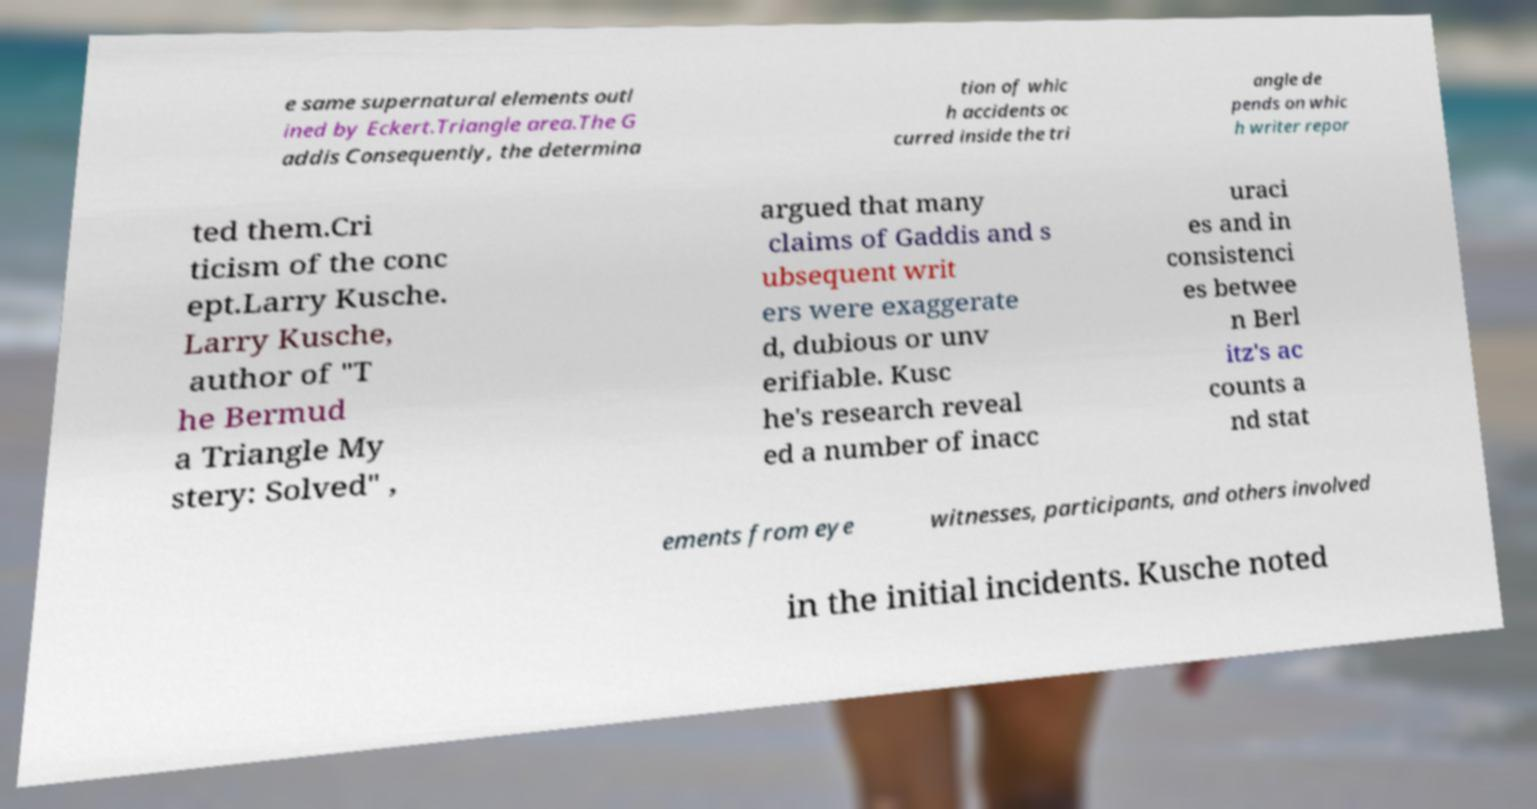Can you read and provide the text displayed in the image?This photo seems to have some interesting text. Can you extract and type it out for me? e same supernatural elements outl ined by Eckert.Triangle area.The G addis Consequently, the determina tion of whic h accidents oc curred inside the tri angle de pends on whic h writer repor ted them.Cri ticism of the conc ept.Larry Kusche. Larry Kusche, author of "T he Bermud a Triangle My stery: Solved" , argued that many claims of Gaddis and s ubsequent writ ers were exaggerate d, dubious or unv erifiable. Kusc he's research reveal ed a number of inacc uraci es and in consistenci es betwee n Berl itz's ac counts a nd stat ements from eye witnesses, participants, and others involved in the initial incidents. Kusche noted 